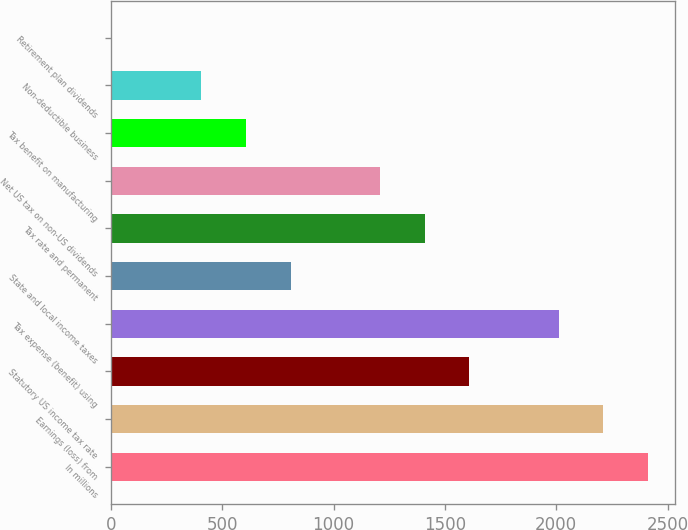Convert chart to OTSL. <chart><loc_0><loc_0><loc_500><loc_500><bar_chart><fcel>In millions<fcel>Earnings (loss) from<fcel>Statutory US income tax rate<fcel>Tax expense (benefit) using<fcel>State and local income taxes<fcel>Tax rate and permanent<fcel>Net US tax on non-US dividends<fcel>Tax benefit on manufacturing<fcel>Non-deductible business<fcel>Retirement plan dividends<nl><fcel>2412.2<fcel>2211.6<fcel>1609.8<fcel>2011<fcel>807.4<fcel>1409.2<fcel>1208.6<fcel>606.8<fcel>406.2<fcel>5<nl></chart> 